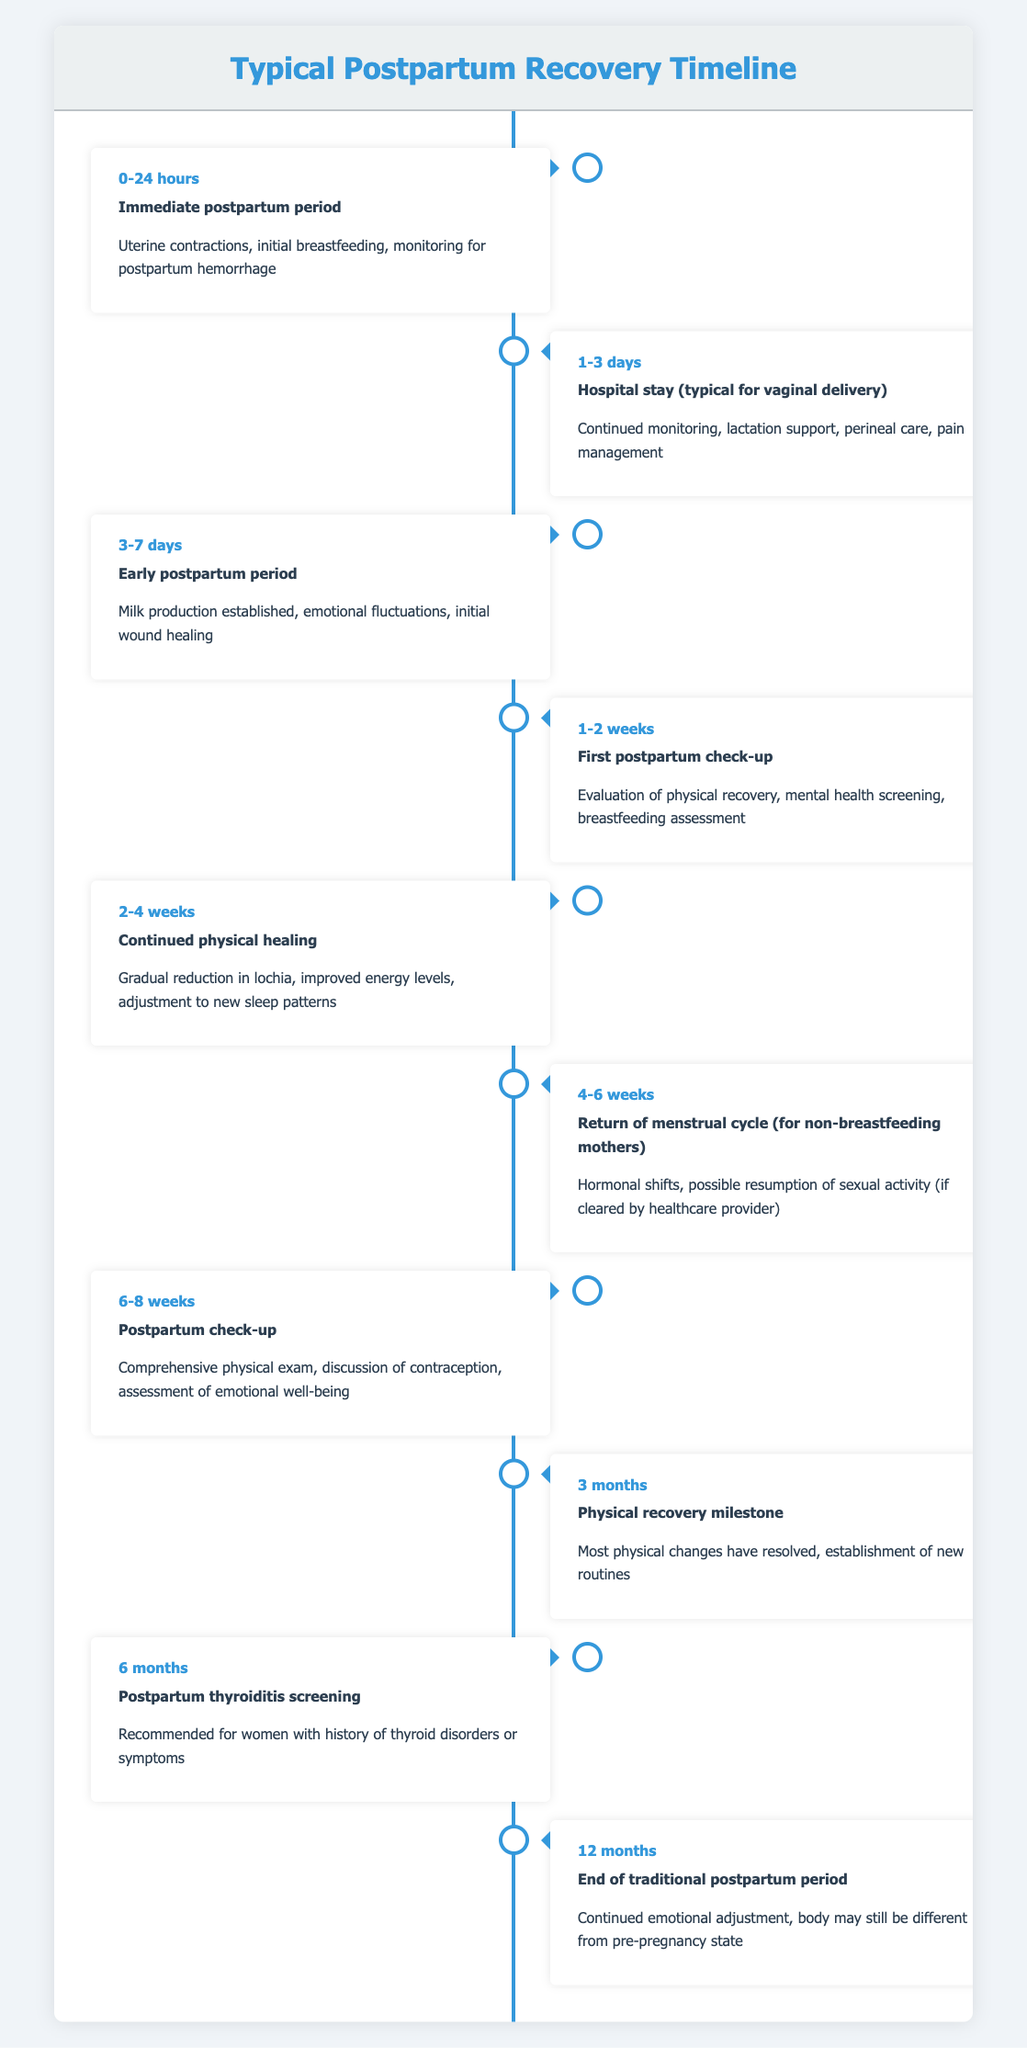What event is associated with the time frame of 0-24 hours? According to the table, the event that occurs in the time frame of 0-24 hours is the "Immediate postpartum period."
Answer: Immediate postpartum period Is the hospital stay typically longer than 3 days after a vaginal delivery? The table states that the hospital stay is "1-3 days" for a typical vaginal delivery, which is less than 4 days. Thus, the statement is false.
Answer: No What physical recovery milestone is expected at 3 months? The table indicates that at 3 months, the milestone is that "most physical changes have resolved, establishment of new routines."
Answer: Most physical changes have resolved, establishment of new routines At which point does the first postpartum check-up occur? Referring to the timeline, the first postpartum check-up occurs between "1-2 weeks" after delivery.
Answer: 1-2 weeks How many major events are detailed in the postpartum timeline from 0-12 months? The table lists a total of 10 events, which range from the immediate postpartum period to the end of the traditional postpartum period at 12 months.
Answer: 10 events Is there a postpartum check-up scheduled at both 6-8 weeks and 12 months? Yes, the table includes a postpartum check-up at "6-8 weeks" and the "end of the traditional postpartum period" at 12 months, indicating two check-ups.
Answer: Yes What is the significance of the "6 months" mark in the postpartum timeline? At the 6-month mark, screening for postpartum thyroiditis is recommended, especially for women with a history of thyroid disorders or symptoms, indicating it is a point of medical evaluation.
Answer: Postpartum thyroiditis screening If a non-breastfeeding mother returns to her menstrual cycle at 4-6 weeks, what other event occurs in that same time frame? The table shows that in addition to the return of the menstrual cycle, there are hormonal shifts and possible resumption of sexual activity in the 4-6 weeks period. Thus, other events include hormonal shifts and potential sexual activity resumption.
Answer: Hormonal shifts, possible resumption of sexual activity What changes occur during the 2-4 weeks postpartum period? During the 2-4 weeks postpartum period, the timeline describes gradual reduction in lochia, improved energy levels, and adjustment to new sleep patterns as key changes.
Answer: Gradual reduction in lochia, improved energy levels, adjustment to new sleep patterns 